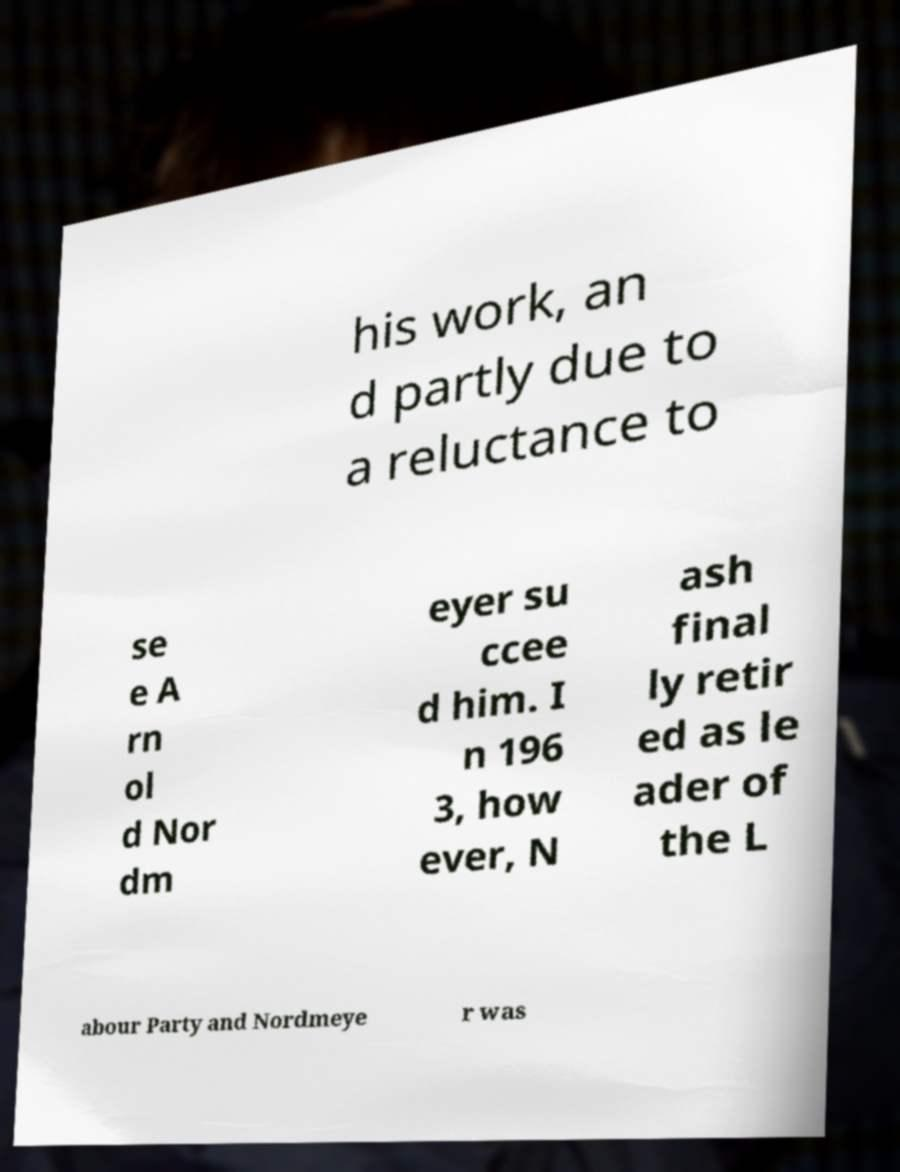Could you extract and type out the text from this image? his work, an d partly due to a reluctance to se e A rn ol d Nor dm eyer su ccee d him. I n 196 3, how ever, N ash final ly retir ed as le ader of the L abour Party and Nordmeye r was 